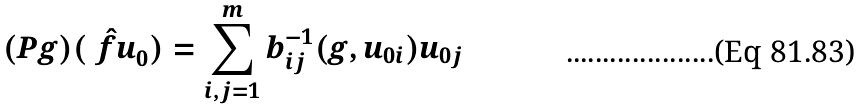Convert formula to latex. <formula><loc_0><loc_0><loc_500><loc_500>( P g ) ( \hat { \ f u } _ { 0 } ) = \sum _ { i , j = 1 } ^ { m } b _ { i j } ^ { - 1 } ( g , u _ { 0 i } ) u _ { 0 j }</formula> 